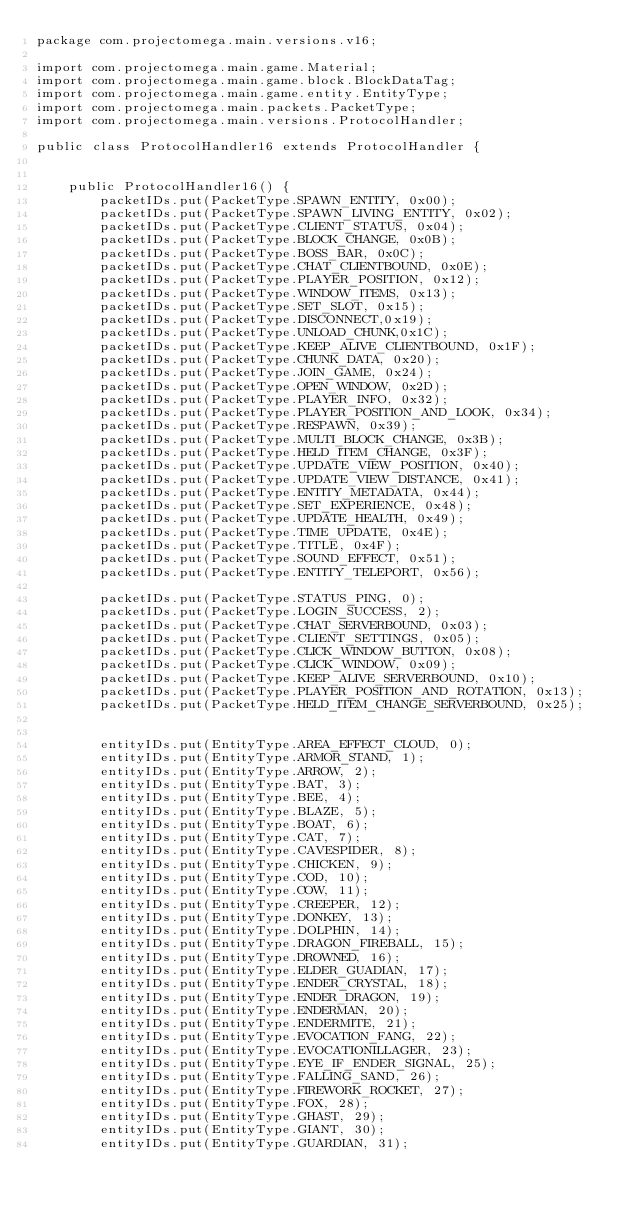Convert code to text. <code><loc_0><loc_0><loc_500><loc_500><_Java_>package com.projectomega.main.versions.v16;

import com.projectomega.main.game.Material;
import com.projectomega.main.game.block.BlockDataTag;
import com.projectomega.main.game.entity.EntityType;
import com.projectomega.main.packets.PacketType;
import com.projectomega.main.versions.ProtocolHandler;

public class ProtocolHandler16 extends ProtocolHandler {


    public ProtocolHandler16() {
        packetIDs.put(PacketType.SPAWN_ENTITY, 0x00);
        packetIDs.put(PacketType.SPAWN_LIVING_ENTITY, 0x02);
        packetIDs.put(PacketType.CLIENT_STATUS, 0x04);
        packetIDs.put(PacketType.BLOCK_CHANGE, 0x0B);
        packetIDs.put(PacketType.BOSS_BAR, 0x0C);
        packetIDs.put(PacketType.CHAT_CLIENTBOUND, 0x0E);
        packetIDs.put(PacketType.PLAYER_POSITION, 0x12);
        packetIDs.put(PacketType.WINDOW_ITEMS, 0x13);
        packetIDs.put(PacketType.SET_SLOT, 0x15);
        packetIDs.put(PacketType.DISCONNECT,0x19);
        packetIDs.put(PacketType.UNLOAD_CHUNK,0x1C);
        packetIDs.put(PacketType.KEEP_ALIVE_CLIENTBOUND, 0x1F);
        packetIDs.put(PacketType.CHUNK_DATA, 0x20);
        packetIDs.put(PacketType.JOIN_GAME, 0x24);
        packetIDs.put(PacketType.OPEN_WINDOW, 0x2D);
        packetIDs.put(PacketType.PLAYER_INFO, 0x32);
        packetIDs.put(PacketType.PLAYER_POSITION_AND_LOOK, 0x34);
        packetIDs.put(PacketType.RESPAWN, 0x39);
        packetIDs.put(PacketType.MULTI_BLOCK_CHANGE, 0x3B);
        packetIDs.put(PacketType.HELD_ITEM_CHANGE, 0x3F);
        packetIDs.put(PacketType.UPDATE_VIEW_POSITION, 0x40);
        packetIDs.put(PacketType.UPDATE_VIEW_DISTANCE, 0x41);
        packetIDs.put(PacketType.ENTITY_METADATA, 0x44);
        packetIDs.put(PacketType.SET_EXPERIENCE, 0x48);
        packetIDs.put(PacketType.UPDATE_HEALTH, 0x49);
        packetIDs.put(PacketType.TIME_UPDATE, 0x4E);
        packetIDs.put(PacketType.TITLE, 0x4F);
        packetIDs.put(PacketType.SOUND_EFFECT, 0x51);
        packetIDs.put(PacketType.ENTITY_TELEPORT, 0x56);

        packetIDs.put(PacketType.STATUS_PING, 0);
        packetIDs.put(PacketType.LOGIN_SUCCESS, 2);
        packetIDs.put(PacketType.CHAT_SERVERBOUND, 0x03);
        packetIDs.put(PacketType.CLIENT_SETTINGS, 0x05);
        packetIDs.put(PacketType.CLICK_WINDOW_BUTTON, 0x08);
        packetIDs.put(PacketType.CLICK_WINDOW, 0x09);
        packetIDs.put(PacketType.KEEP_ALIVE_SERVERBOUND, 0x10);
        packetIDs.put(PacketType.PLAYER_POSITION_AND_ROTATION, 0x13);
        packetIDs.put(PacketType.HELD_ITEM_CHANGE_SERVERBOUND, 0x25);


        entityIDs.put(EntityType.AREA_EFFECT_CLOUD, 0);
        entityIDs.put(EntityType.ARMOR_STAND, 1);
        entityIDs.put(EntityType.ARROW, 2);
        entityIDs.put(EntityType.BAT, 3);
        entityIDs.put(EntityType.BEE, 4);
        entityIDs.put(EntityType.BLAZE, 5);
        entityIDs.put(EntityType.BOAT, 6);
        entityIDs.put(EntityType.CAT, 7);
        entityIDs.put(EntityType.CAVESPIDER, 8);
        entityIDs.put(EntityType.CHICKEN, 9);
        entityIDs.put(EntityType.COD, 10);
        entityIDs.put(EntityType.COW, 11);
        entityIDs.put(EntityType.CREEPER, 12);
        entityIDs.put(EntityType.DONKEY, 13);
        entityIDs.put(EntityType.DOLPHIN, 14);
        entityIDs.put(EntityType.DRAGON_FIREBALL, 15);
        entityIDs.put(EntityType.DROWNED, 16);
        entityIDs.put(EntityType.ELDER_GUADIAN, 17);
        entityIDs.put(EntityType.ENDER_CRYSTAL, 18);
        entityIDs.put(EntityType.ENDER_DRAGON, 19);
        entityIDs.put(EntityType.ENDERMAN, 20);
        entityIDs.put(EntityType.ENDERMITE, 21);
        entityIDs.put(EntityType.EVOCATION_FANG, 22);
        entityIDs.put(EntityType.EVOCATIONILLAGER, 23);
        entityIDs.put(EntityType.EYE_IF_ENDER_SIGNAL, 25);
        entityIDs.put(EntityType.FALLING_SAND, 26);
        entityIDs.put(EntityType.FIREWORK_ROCKET, 27);
        entityIDs.put(EntityType.FOX, 28);
        entityIDs.put(EntityType.GHAST, 29);
        entityIDs.put(EntityType.GIANT, 30);
        entityIDs.put(EntityType.GUARDIAN, 31);</code> 